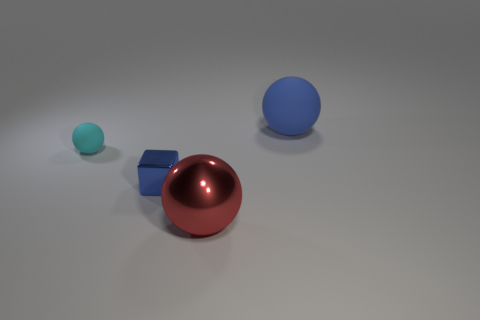There is a sphere behind the tiny cyan thing; what is its size? The sphere behind the tiny cyan object appears to be significantly larger; it's about twice the diameter of the smaller blue sphere next to it, making it the largest object in the image. 